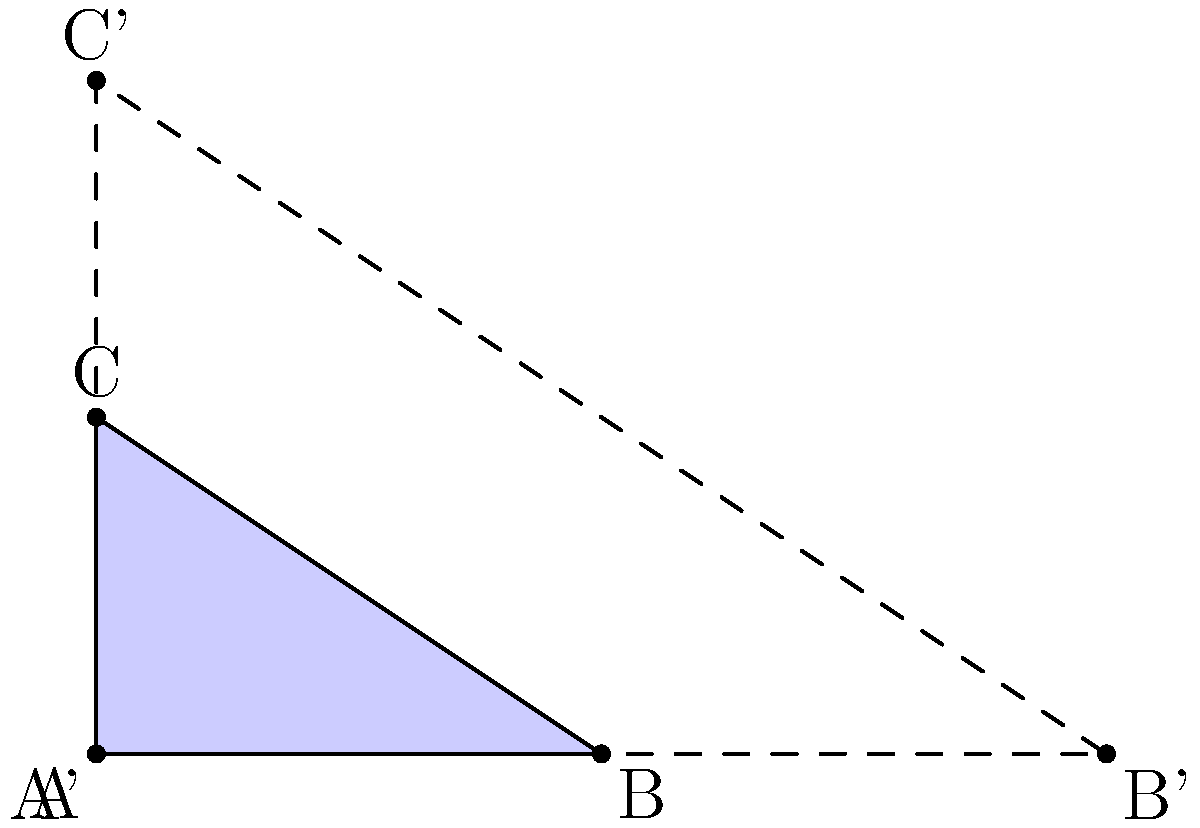In your AI-powered legal research platform, you're developing a feature to analyze contract layouts. Consider a triangular logo with vertices at A(0,0), B(3,0), and C(0,2). If this logo is scaled by a factor of 2, what is the ratio of the new area to the original area? Let's approach this step-by-step:

1) The original triangle ABC has a base of 3 units and a height of 2 units.

2) The area of the original triangle is:
   $$A_1 = \frac{1}{2} \times base \times height = \frac{1}{2} \times 3 \times 2 = 3$$ square units

3) When we scale the triangle by a factor of 2, all linear dimensions are doubled.
   The new triangle A'B'C' has a base of 6 units and a height of 4 units.

4) The area of the new triangle is:
   $$A_2 = \frac{1}{2} \times 6 \times 4 = 12$$ square units

5) The ratio of the new area to the original area is:
   $$\frac{A_2}{A_1} = \frac{12}{3} = 4$$

6) This result can be generalized: when a 2D shape is scaled by a factor of k, its area is scaled by a factor of $k^2$.
   In this case, $k = 2$, so the area scale factor is $2^2 = 4$.

Therefore, the new area is 4 times the original area.
Answer: 4:1 